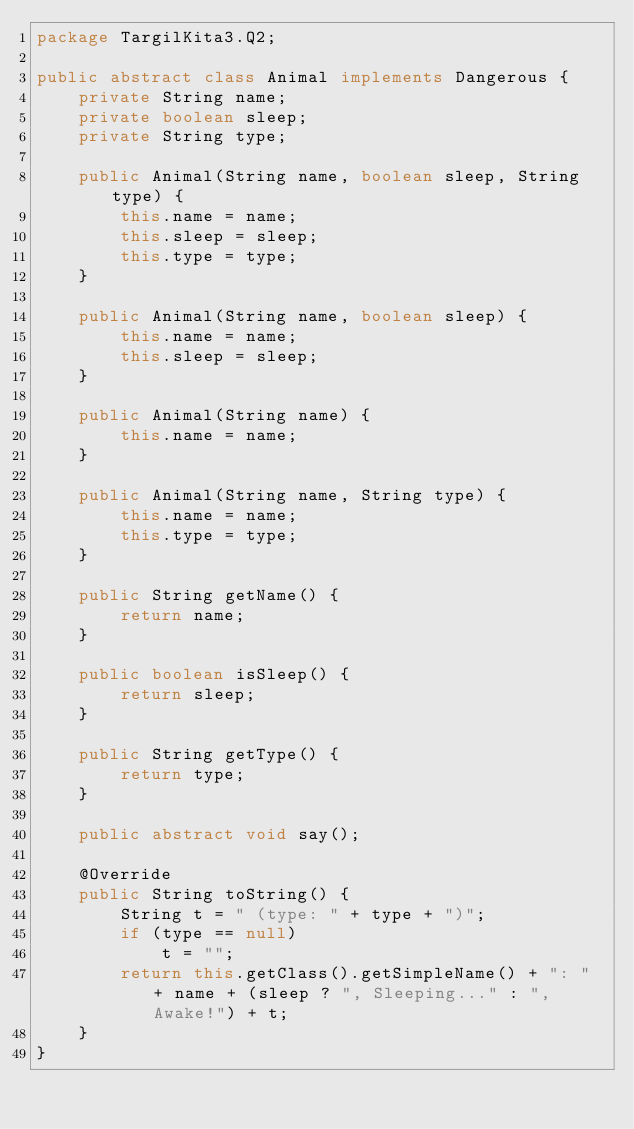<code> <loc_0><loc_0><loc_500><loc_500><_Java_>package TargilKita3.Q2;

public abstract class Animal implements Dangerous {
    private String name;
    private boolean sleep;
    private String type;

    public Animal(String name, boolean sleep, String type) {
        this.name = name;
        this.sleep = sleep;
        this.type = type;
    }

    public Animal(String name, boolean sleep) {
        this.name = name;
        this.sleep = sleep;
    }

    public Animal(String name) {
        this.name = name;
    }

    public Animal(String name, String type) {
        this.name = name;
        this.type = type;
    }

    public String getName() {
        return name;
    }

    public boolean isSleep() {
        return sleep;
    }

    public String getType() {
        return type;
    }

    public abstract void say();

    @Override
    public String toString() {
        String t = " (type: " + type + ")";
        if (type == null)
            t = "";
        return this.getClass().getSimpleName() + ": " + name + (sleep ? ", Sleeping..." : ", Awake!") + t;
    }
}
</code> 